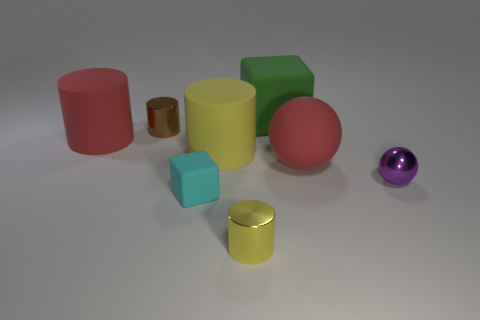Do the objects share a common material or are there variations? There are variations in materials. While most objects have a matte finish, a few cylinders show a metallic and reflective finish, suggesting different materials or surface treatments. Can you describe those variations in more detail? Certainly. The large red and green cylinders have a matte, slightly textured finish, which diffuses the light. The smaller golden and yellow cylinders exhibit a glossy surface, reflecting light more clearly and giving off a metallic sheen. 